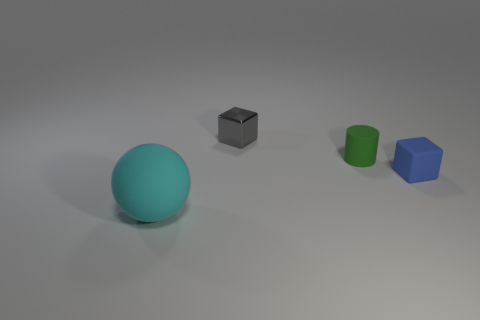Are there any other things that are the same size as the ball?
Offer a terse response. No. Is the number of small green objects that are left of the green thing less than the number of small cubes that are behind the matte sphere?
Your response must be concise. Yes. What number of things are matte things that are behind the large cyan matte ball or green cylinders?
Your answer should be compact. 2. Does the block that is behind the cylinder have the same size as the small green rubber cylinder?
Your response must be concise. Yes. Is the number of tiny blocks that are behind the small blue matte object less than the number of green spheres?
Your answer should be very brief. No. What material is the other cube that is the same size as the blue block?
Your response must be concise. Metal. What number of small things are cyan matte spheres or metallic blocks?
Offer a very short reply. 1. How many things are either cubes that are to the right of the tiny green cylinder or cubes behind the tiny blue rubber object?
Provide a short and direct response. 2. Are there fewer large rubber spheres than small objects?
Your response must be concise. Yes. The blue thing that is the same size as the cylinder is what shape?
Offer a terse response. Cube. 